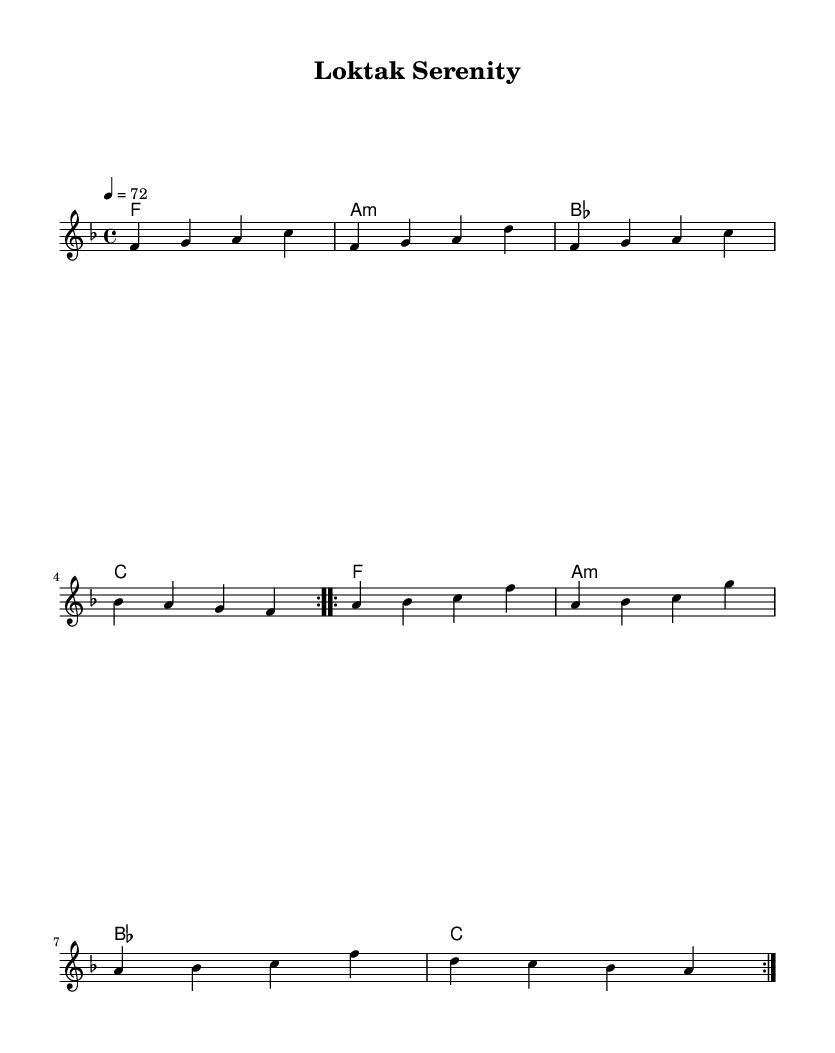What is the key signature of this music? The key signature indicated at the beginning of the score shows one flat, which corresponds to F major.
Answer: F major What is the time signature of this piece? The time signature is displayed as 4 over 4 at the beginning, which means there are four beats in each measure.
Answer: 4/4 What is the tempo marking indicated in the score? The tempo marking states "4 = 72," meaning there are 72 beats per minute, which dictates the speed of the music.
Answer: 72 How many measures are in the main theme? The main theme is repeated twice, and consists of 4 measures, so we multiply 4 by 2, totaling 8 measures.
Answer: 8 What chord follows F in the progression? The chord progression indicates that the chord following F is A minor, listed directly after it in the harmonic section.
Answer: A minor Which clef is used for the melody? The melody is represented with a treble clef, which is shown at the start of the melody staff.
Answer: Treble clef What is the overall mood intended by the composition? The title "Loktak Serenity" suggests a calming and peaceful ambiance, influencing the overall mood of the music to reflect relaxation and tranquility.
Answer: Serenity 